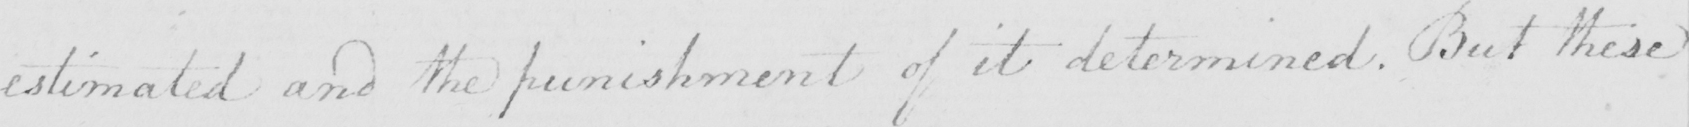What is written in this line of handwriting? estimated and the punishment of it determined . But these 